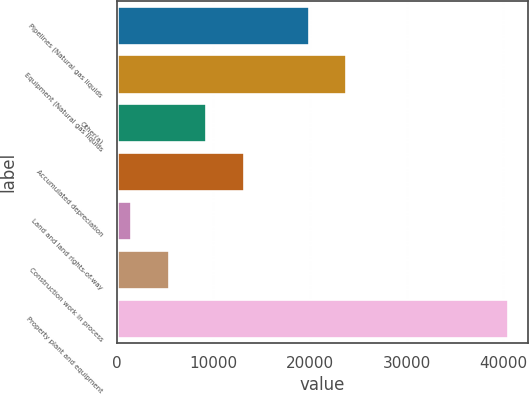<chart> <loc_0><loc_0><loc_500><loc_500><bar_chart><fcel>Pipelines (Natural gas liquids<fcel>Equipment (Natural gas liquids<fcel>Other(a)<fcel>Accumulated depreciation<fcel>Land and land rights-of-way<fcel>Construction work in process<fcel>Property plant and equipment<nl><fcel>19855<fcel>23764.7<fcel>9269.4<fcel>13179.1<fcel>1450<fcel>5359.7<fcel>40547<nl></chart> 